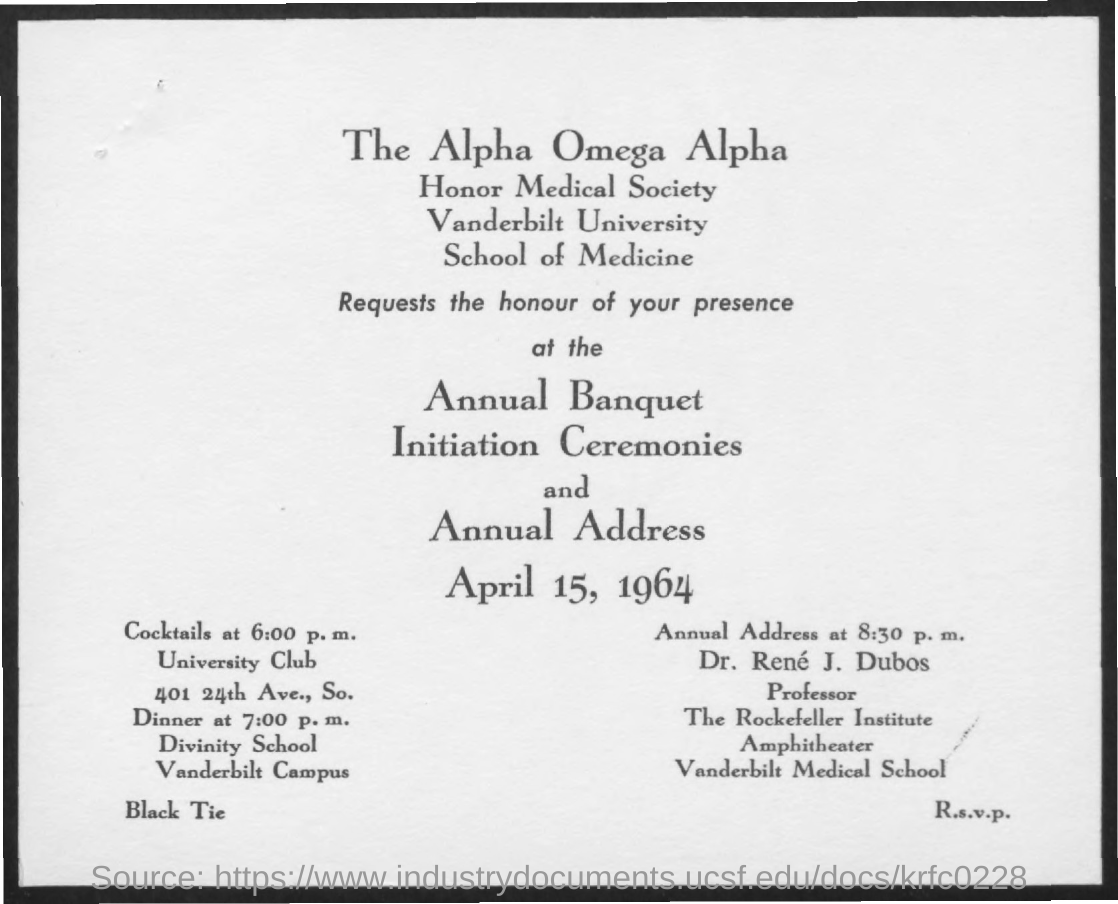What is the source of this document?
Your answer should be compact. Https://www.industrydocuments.ucsf.edu/docs/krfc0228. When is the annual address is conducted?
Offer a very short reply. April 15, 1964. Which Society comes under Vanderbilt University ?
Your response must be concise. Honor Medical Society. At which school,does the dinner is arranged?
Your answer should be compact. Divinity School. In which campus,does the 'Divinity School' is located ?
Your answer should be compact. Vanderbilt Campus. What is the designation of " Dr. Rene J. Dubos" ?
Ensure brevity in your answer.  Professor. In which school,does " Dr. Rene J. Dubos" works?
Provide a short and direct response. Vanderbilt Medical School. Which university conduct the program on April 15 ?
Your answer should be very brief. Vanderbilt University. 